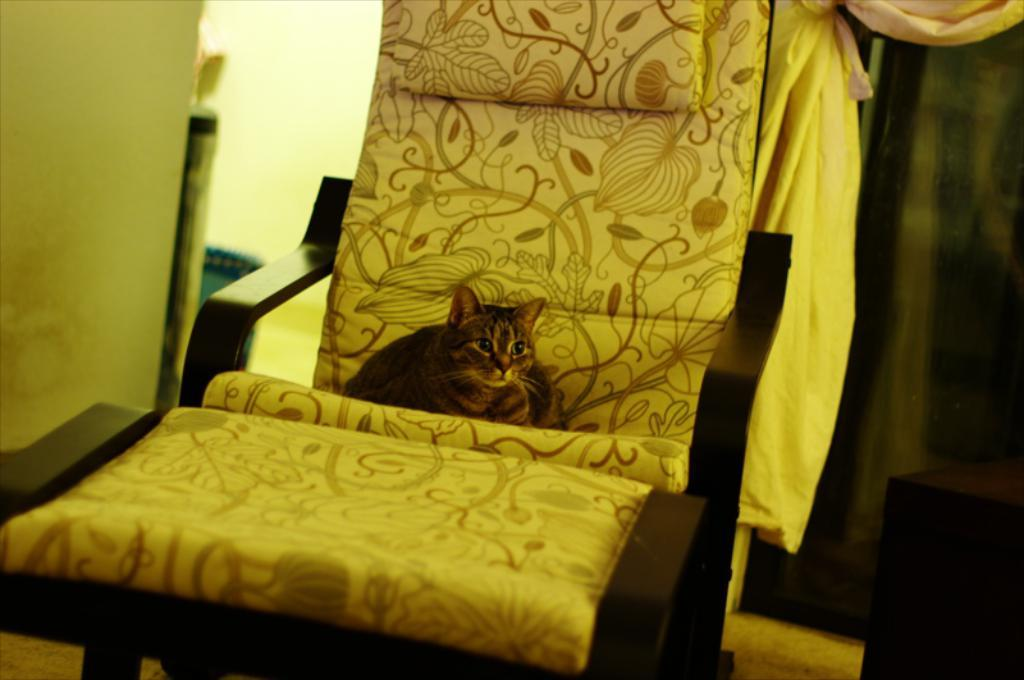What can be seen in the background of the image? There is a wall in the background of the image. What animal is sitting on a chair in the image? There is a cat sitting on a chair in the image. What else is visible in the image besides the cat and the wall? There are objects visible in the image. What type of material is present in the image? There is a cloth present in the image. What grade did the cat receive for its driving skills in the image? There is no mention of driving or grades in the image, as it features a cat sitting on a chair with a wall and objects in the background. 